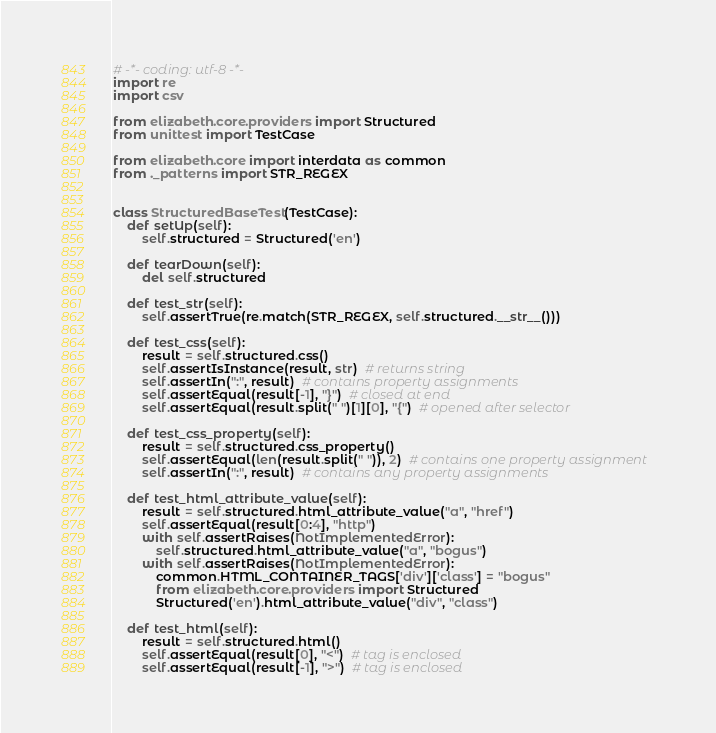Convert code to text. <code><loc_0><loc_0><loc_500><loc_500><_Python_># -*- coding: utf-8 -*-
import re
import csv

from elizabeth.core.providers import Structured
from unittest import TestCase

from elizabeth.core import interdata as common
from ._patterns import STR_REGEX


class StructuredBaseTest(TestCase):
    def setUp(self):
        self.structured = Structured('en')

    def tearDown(self):
        del self.structured

    def test_str(self):
        self.assertTrue(re.match(STR_REGEX, self.structured.__str__()))

    def test_css(self):
        result = self.structured.css()
        self.assertIsInstance(result, str)  # returns string
        self.assertIn(":", result)  # contains property assignments
        self.assertEqual(result[-1], "}")  # closed at end
        self.assertEqual(result.split(" ")[1][0], "{")  # opened after selector

    def test_css_property(self):
        result = self.structured.css_property()
        self.assertEqual(len(result.split(" ")), 2)  # contains one property assignment
        self.assertIn(":", result)  # contains any property assignments

    def test_html_attribute_value(self):
        result = self.structured.html_attribute_value("a", "href")
        self.assertEqual(result[0:4], "http")
        with self.assertRaises(NotImplementedError):
            self.structured.html_attribute_value("a", "bogus")
        with self.assertRaises(NotImplementedError):
            common.HTML_CONTAINER_TAGS['div']['class'] = "bogus"
            from elizabeth.core.providers import Structured
            Structured('en').html_attribute_value("div", "class")

    def test_html(self):
        result = self.structured.html()
        self.assertEqual(result[0], "<")  # tag is enclosed
        self.assertEqual(result[-1], ">")  # tag is enclosed
</code> 